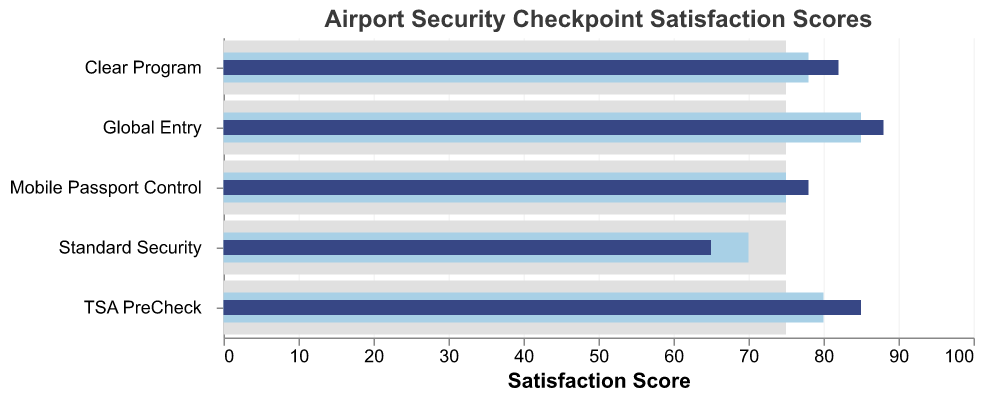What is the title of the chart? The title is shown at the top of the chart, indicating the subject being visualized.
Answer: Airport Security Checkpoint Satisfaction Scores Which category has the highest actual satisfaction score? To find the highest actual satisfaction score, we look for the category bar that extends the farthest towards higher values on the x-axis.
Answer: Global Entry What is the benchmark score for all categories? The benchmark score is marked as a reference bar. Each category's bar indicating the benchmark is in the same position along the x-axis.
Answer: 75 Among the categories, which one has an actual score lower than the comparative score? Comparing each of the actual scores with their corresponding comparative scores: the category where the actual score bar does not reach or surpass the comparative score bar is identified.
Answer: Standard Security What is the difference in actual satisfaction scores between TSA PreCheck and Standard Security? The actual score for TSA PreCheck is 85, and for Standard Security, it is 65. Subtract the lower score from the higher score (85 - 65).
Answer: 20 Which category has the smallest difference between comparative and actual scores? Calculate the difference between actual and comparative scores for each category and identify the smallest gap. (For TSA PreCheck: 85-80 = 5, Clear Program: 82-78 = 4, Standard Security: 65-70 = -5, Mobile Passport Control: 78-75 = 3, Global Entry: 88-85 = 3).
Answer: Mobile Passport Control and Global Entry How many categories exceed the benchmark in their actual satisfaction scores? Count the categories where the actual satisfaction bar extends beyond the benchmark bar on the x-axis. (TSA PreCheck, Clear Program, Mobile Passport Control, Global Entry).
Answer: 4 Which category shows an actual satisfaction score close to the comparative score? Look for categories where the actual score bar is almost aligned with the comparative score bar.
Answer: Mobile Passport Control and Global Entry What is the average actual satisfaction score across all categories? Add up the actual satisfaction scores for all categories and divide by the number of categories (85 + 82 + 65 + 78 + 88)/5.
Answer: 79.6 Between Clear Program and Mobile Passport Control, which category has a higher comparative score? Look at the comparative score bars for both categories and compare their lengths along the x-axis.
Answer: Clear Program 